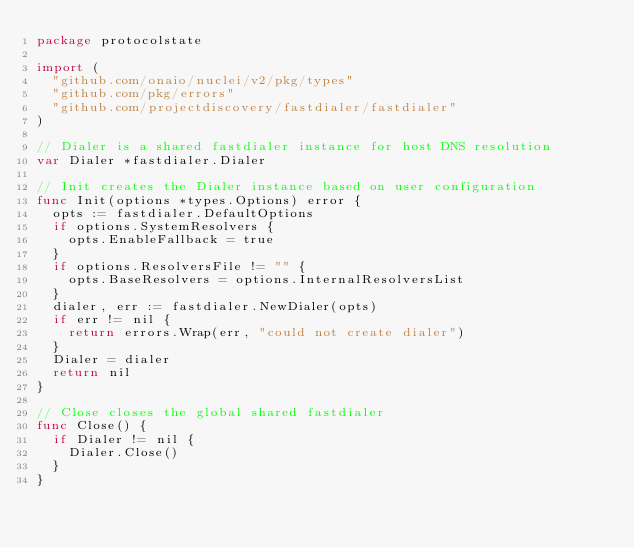<code> <loc_0><loc_0><loc_500><loc_500><_Go_>package protocolstate

import (
	"github.com/onaio/nuclei/v2/pkg/types"
	"github.com/pkg/errors"
	"github.com/projectdiscovery/fastdialer/fastdialer"
)

// Dialer is a shared fastdialer instance for host DNS resolution
var Dialer *fastdialer.Dialer

// Init creates the Dialer instance based on user configuration
func Init(options *types.Options) error {
	opts := fastdialer.DefaultOptions
	if options.SystemResolvers {
		opts.EnableFallback = true
	}
	if options.ResolversFile != "" {
		opts.BaseResolvers = options.InternalResolversList
	}
	dialer, err := fastdialer.NewDialer(opts)
	if err != nil {
		return errors.Wrap(err, "could not create dialer")
	}
	Dialer = dialer
	return nil
}

// Close closes the global shared fastdialer
func Close() {
	if Dialer != nil {
		Dialer.Close()
	}
}
</code> 